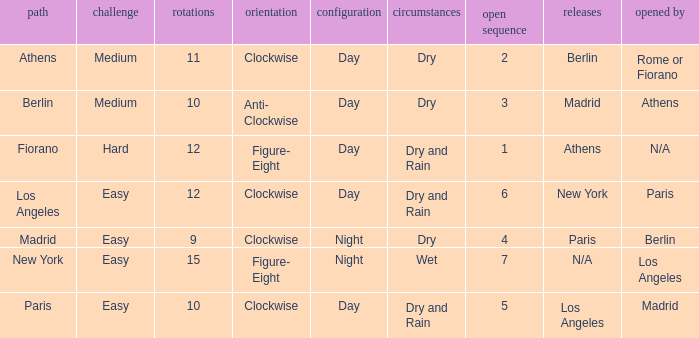What is the lowest unlock order for the athens circuit? 2.0. 